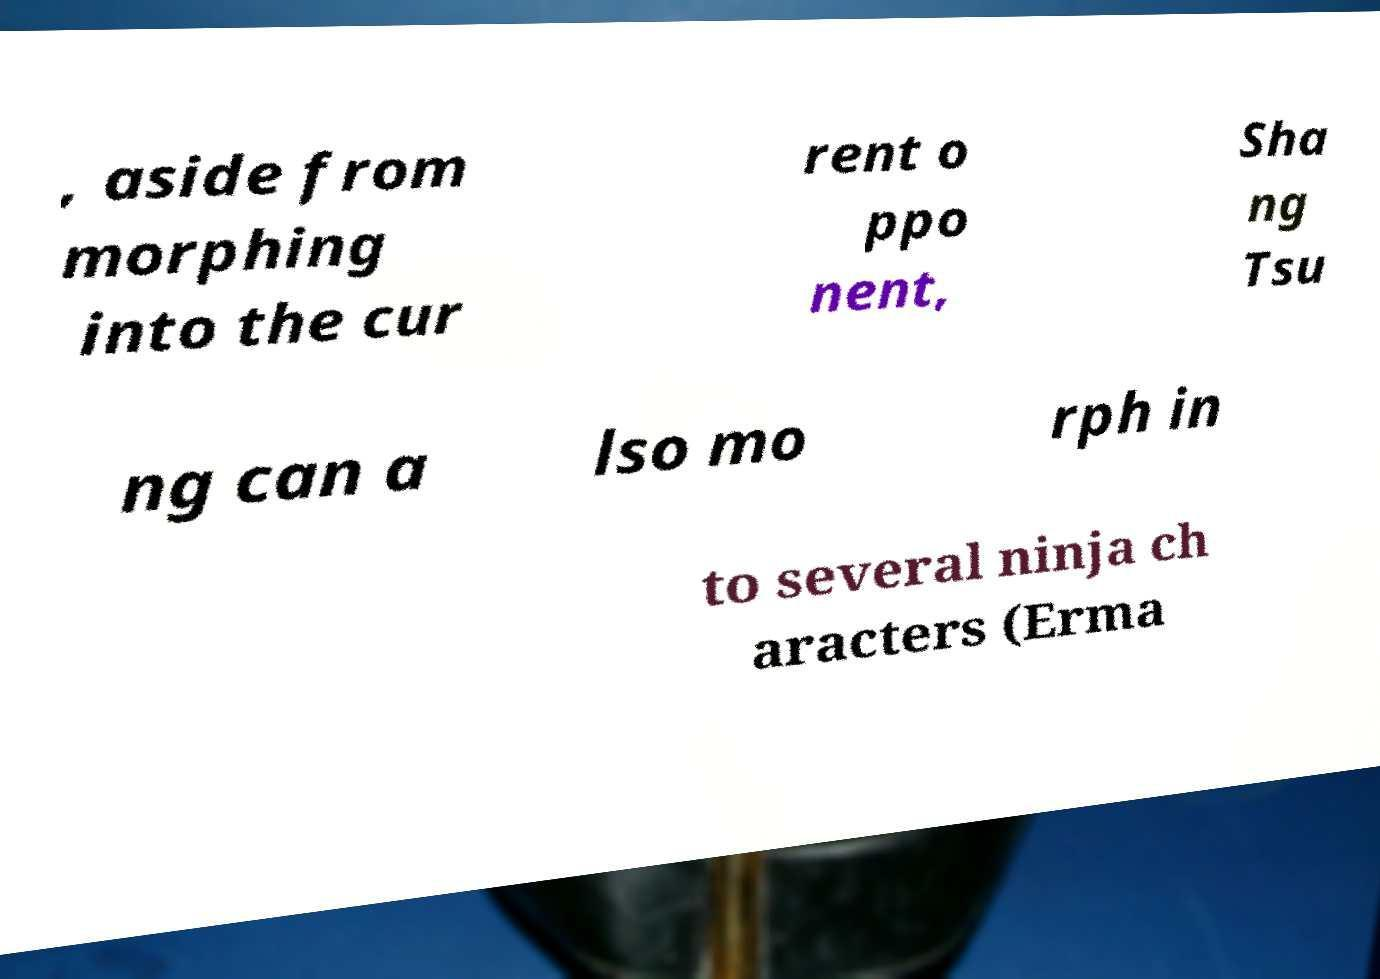Can you read and provide the text displayed in the image?This photo seems to have some interesting text. Can you extract and type it out for me? , aside from morphing into the cur rent o ppo nent, Sha ng Tsu ng can a lso mo rph in to several ninja ch aracters (Erma 